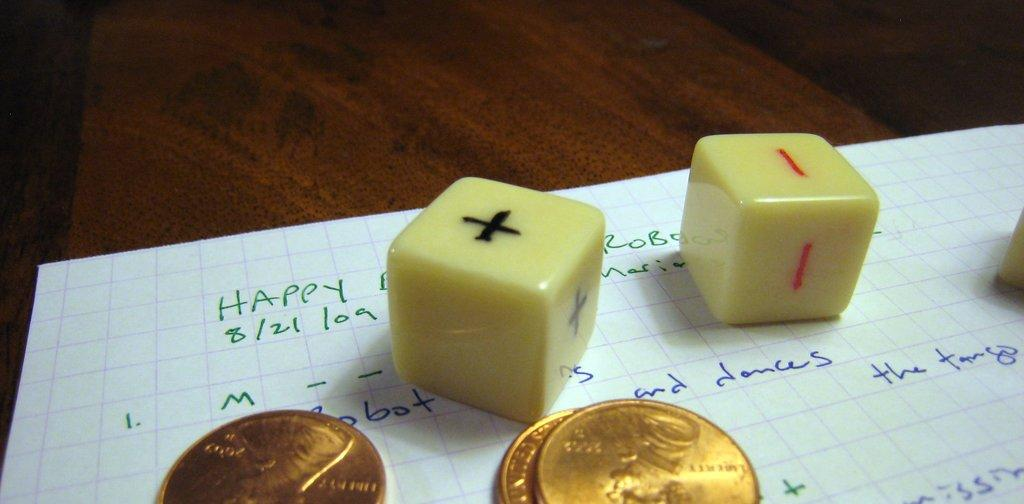<image>
Write a terse but informative summary of the picture. Two dice and three pennies sit on a piece of paper with the word happy written in the upper left corner. 